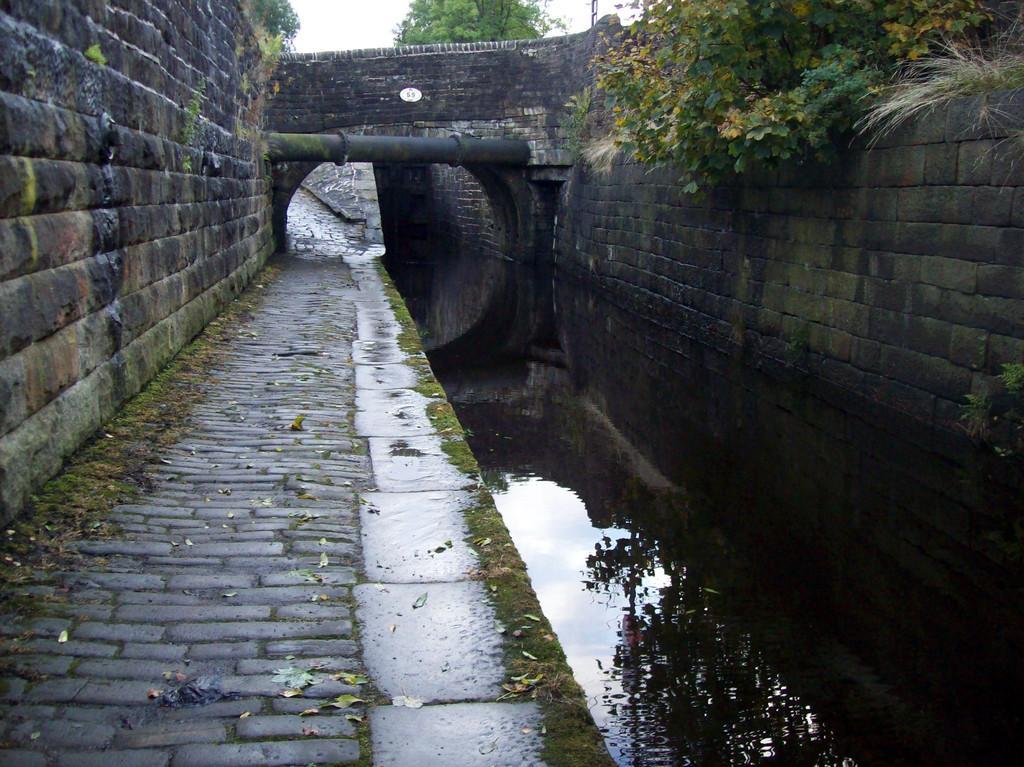In one or two sentences, can you explain what this image depicts? On the left and right side we can see the wall. In the middle we can see water. In the background there is a tunnel, pipe, trees, pole and sky. 